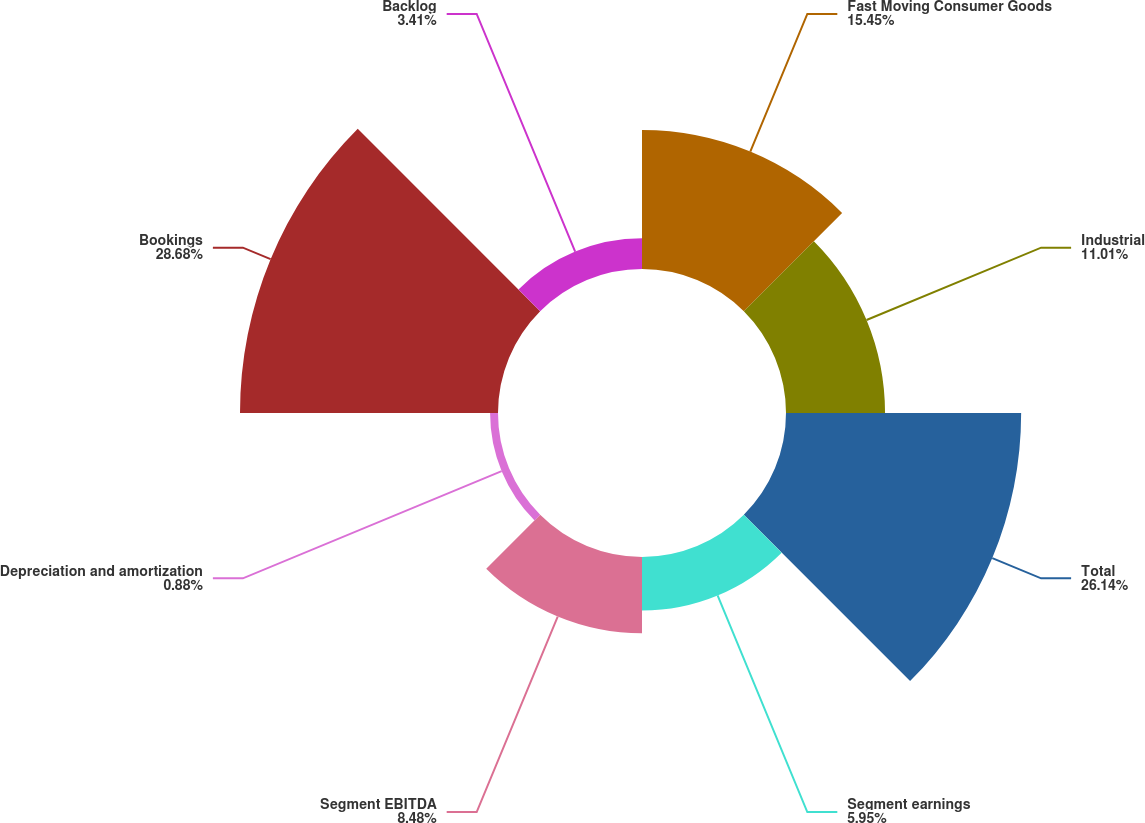Convert chart. <chart><loc_0><loc_0><loc_500><loc_500><pie_chart><fcel>Fast Moving Consumer Goods<fcel>Industrial<fcel>Total<fcel>Segment earnings<fcel>Segment EBITDA<fcel>Depreciation and amortization<fcel>Bookings<fcel>Backlog<nl><fcel>15.45%<fcel>11.01%<fcel>26.14%<fcel>5.95%<fcel>8.48%<fcel>0.88%<fcel>28.68%<fcel>3.41%<nl></chart> 